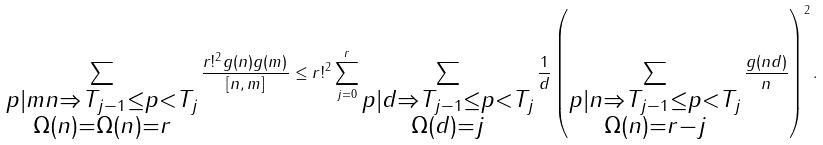<formula> <loc_0><loc_0><loc_500><loc_500>\sum _ { \substack { p | m n \Rightarrow T _ { j - 1 } \leq p < T _ { j } \\ \Omega ( n ) = \Omega ( n ) = r } } \frac { r ! ^ { 2 } g ( n ) g ( m ) } { [ n , m ] } \leq r ! ^ { 2 } \sum _ { j = 0 } ^ { r } \sum _ { \substack { p | d \Rightarrow T _ { j - 1 } \leq p < T _ { j } \\ \Omega ( d ) = j } } \frac { 1 } { d } \left ( \sum _ { \substack { p | n \Rightarrow T _ { j - 1 } \leq p < T _ { j } \\ \Omega ( n ) = r - j } } \frac { g ( n d ) } { n } \right ) ^ { 2 } .</formula> 